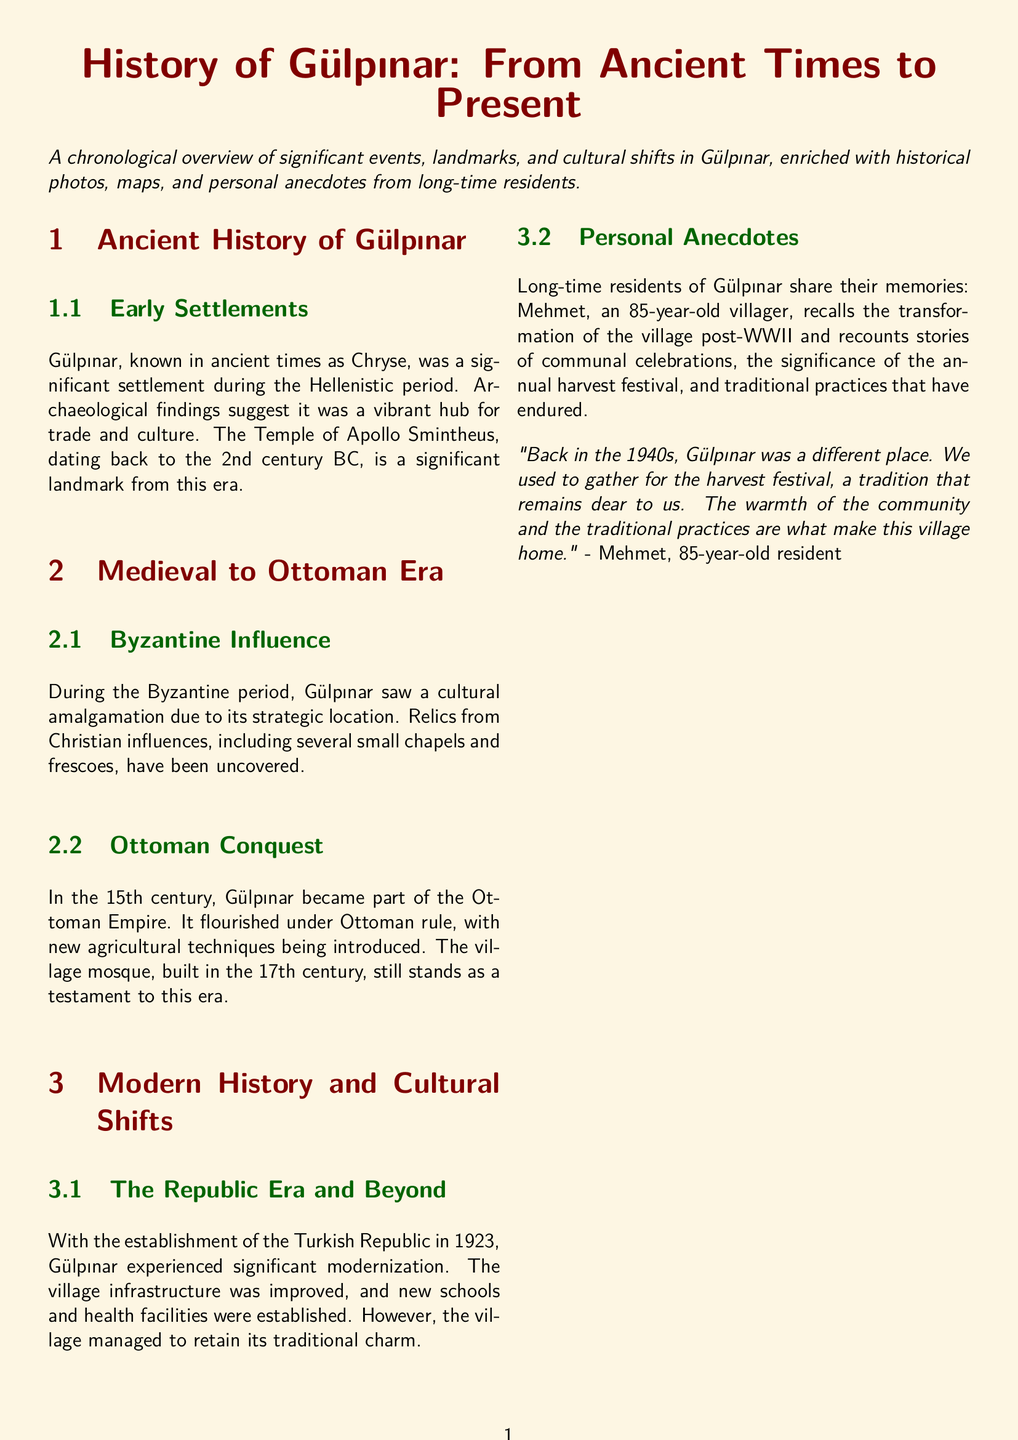What was Gülpınar known as in ancient times? The ancient name of Gülpınar is mentioned as Chryse.
Answer: Chryse What significant landmark from the Hellenistic period exists in Gülpınar? The document states that the Temple of Apollo Smintheus is a significant landmark.
Answer: Temple of Apollo Smintheus In which century was the village mosque built? The document reports that the village mosque was built in the 17th century.
Answer: 17th century What significant change happened in Gülpınar after 1923? The establishment of the Turkish Republic brought modernization to Gülpınar.
Answer: Modernization Who is mentioned as sharing personal anecdotes about Gülpınar? The document mentions a resident named Mehmet who shares his memories.
Answer: Mehmet What tradition does Mehmet recall from the 1940s? The document highlights the harvest festival as a cherished tradition.
Answer: Harvest festival How old is Mehmet, the resident sharing anecdotes? The document states that Mehmet is 85 years old.
Answer: 85 What type of photos are included as resources in the document? The resources section lists historical photos such as ruins of the Temple of Apollo Smintheus.
Answer: Ruins of the Temple of Apollo Smintheus What year marks the establishment of the Turkish Republic? The document specifies that the Turkish Republic was established in 1923.
Answer: 1923 